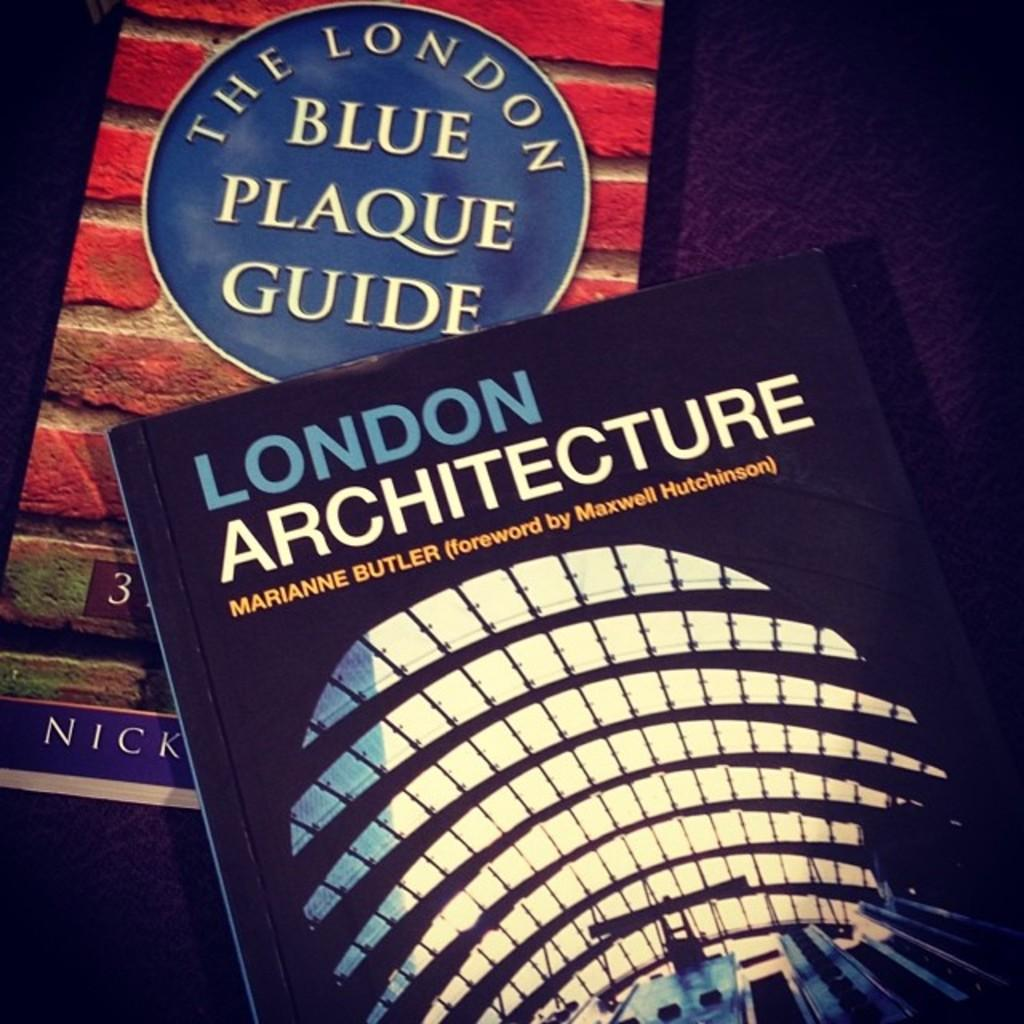<image>
Write a terse but informative summary of the picture. London Architecture and The London Blue Plaque Guide books. 